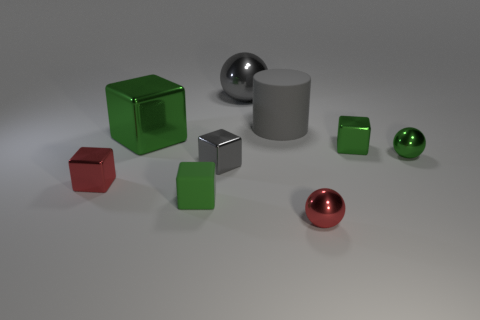Subtract all green metal balls. How many balls are left? 2 Add 1 big gray matte things. How many objects exist? 10 Subtract all green blocks. How many blocks are left? 2 Subtract all spheres. How many objects are left? 6 Subtract 1 cubes. How many cubes are left? 4 Subtract 0 yellow blocks. How many objects are left? 9 Subtract all cyan cubes. Subtract all brown cylinders. How many cubes are left? 5 Subtract all cyan balls. How many purple cylinders are left? 0 Subtract all big green metallic cylinders. Subtract all big gray rubber cylinders. How many objects are left? 8 Add 1 small red things. How many small red things are left? 3 